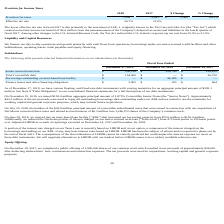From Chefs Wharehouse's financial document, What is the value of senior secured term loan for fiscal years 2019 and 2018 respectively? The document shows two values: $238,129 and $239,745 (in thousands). From the document: "Senior secured term loan $ 238,129 $ 239,745 $ 238,435 Senior secured term loan $ 238,129 $ 239,745 $ 238,435..." Also, What is the value of finance leases and other financing obligations for fiscal years 2019 and 2018 respectively? The document shows two values: $3,905 and $193 (in thousands). From the document: "Finance leases and other financing obligations $ 3,905 $ 193 $ 664 leases and other financing obligations $ 3,905 $ 193 $ 664..." Also, What is the value of total convertible debt in fiscal year 2019? According to the financial document, $154,000 (in thousands). The relevant text states: "Total Convertible debt $ 154,000 $ — $ 36,750..." Also, can you calculate: What is the percentage change in the finance leases and other financing obligations between fiscal years 2018 and 2019? To answer this question, I need to perform calculations using the financial data. The calculation is: (3,905-193)/193, which equals 1923.32 (percentage). This is based on the information: "leases and other financing obligations $ 3,905 $ 193 $ 664 Finance leases and other financing obligations $ 3,905 $ 193 $ 664..." The key data points involved are: 193, 3,905. Additionally, Which fiscal year has a higher value of senior secured term loan? According to the financial document, 2018. The relevant text states: "December 27, 2019 December 28, 2018 December 29, 2017..." Also, can you calculate: What is the average finance leases and other financing obligations for fiscal years 2018 and 2019? To answer this question, I need to perform calculations using the financial data. The calculation is: (3,905+ 193)/2, which equals 2049 (in thousands). This is based on the information: "leases and other financing obligations $ 3,905 $ 193 $ 664 Finance leases and other financing obligations $ 3,905 $ 193 $ 664..." The key data points involved are: 193, 3,905. 